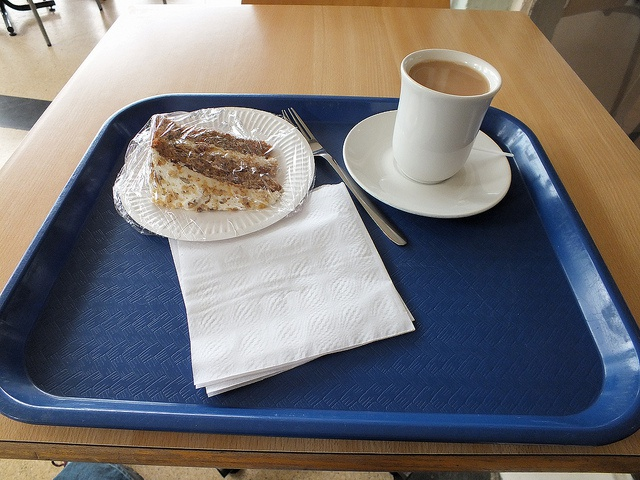Describe the objects in this image and their specific colors. I can see dining table in navy, lightgray, black, and tan tones, cup in black, darkgray, lightgray, and gray tones, cake in black, tan, gray, and maroon tones, and fork in black, gray, and darkgray tones in this image. 